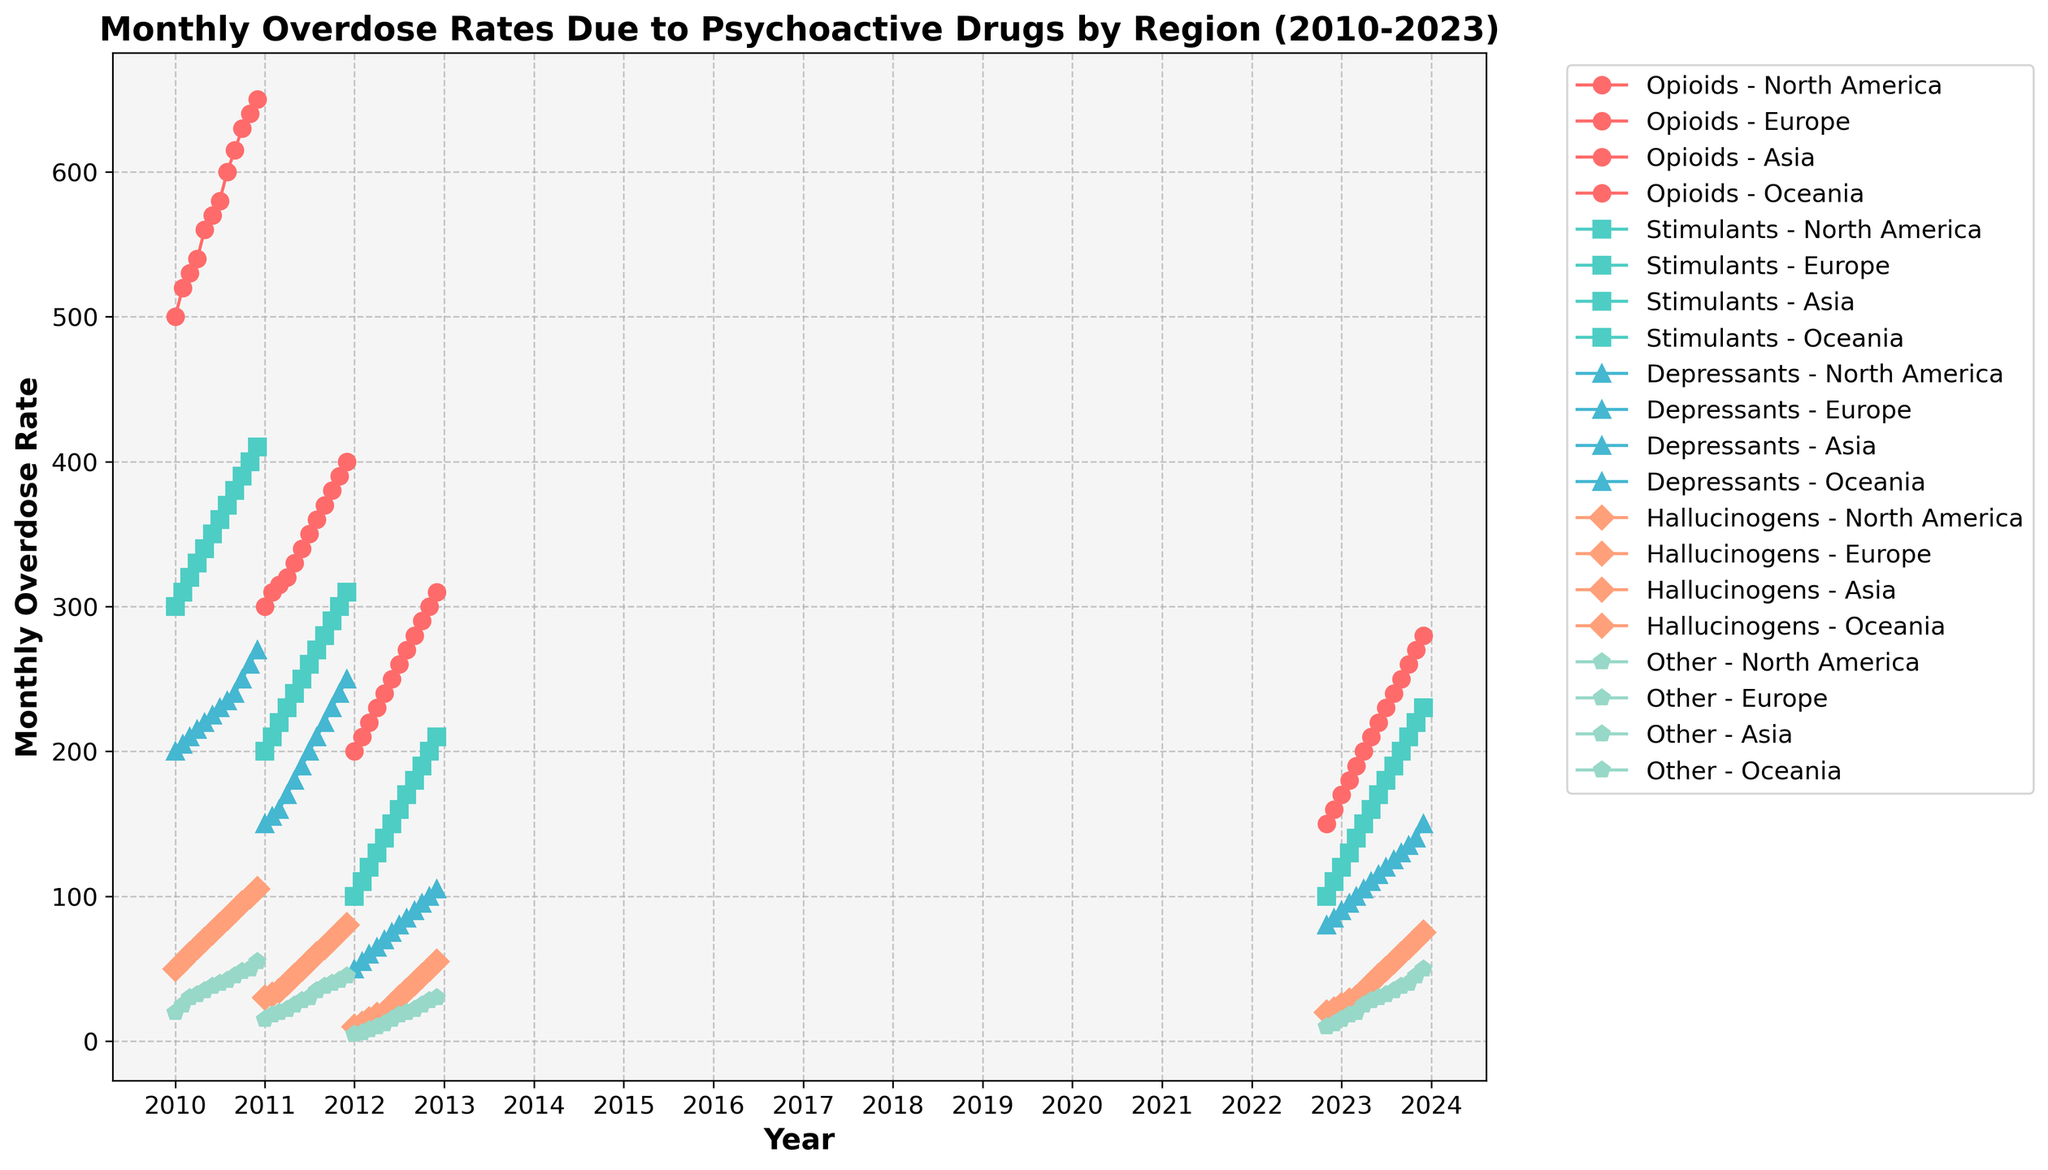What's the title of the figure? The title is typically displayed at the top of the figure and provides a summary of what the plot represents. In this case, it is located at the top center.
Answer: Monthly Overdose Rates Due to Psychoactive Drugs by Region (2010-2023) What does the y-axis represent? The y-axis represents the dependent variable, which in this case is the "Monthly Overdose Rate." This is clearly labeled on the y-axis.
Answer: Monthly Overdose Rate Which drug category in North America had the highest initial overdose rate at the start of the data range? To find this, look at the first timeframe (2010-01) for North America and compare the overdose rates of the different drug categories. Opioids had the highest rate.
Answer: Opioids In which year did Europe start seeing an increase in overdose rates due to depressants? To find this, look at the plot lines related to depressants in Europe and identify the year when these lines first start increasing. It started increasing from the data initially available in 2011-03 onwards.
Answer: 2011 Among all regions, which region reported an overdose rate for hallucinogens in 2023-08? Look for the data points corresponding to 2023-08 for each region and check the values for hallucinogens. Oceania reported data for this period.
Answer: Oceania How did the overdose rate for stimulants in Asia change from 2012-01 to 2012-12? Compare the overdose rates for stimulants in Asia at two time points, 2012-01 and 2012-12.
Answer: It increased from 100 to 210 Which region saw the highest increase in opioid overdose rates from their respective starting period to the end of the data range? To determine this, calculate the difference between the first and last data points for opioids in each region, then compare these increases. North America saw an increase from 500 to 650, Europe from 300 to 400, Asia from 200 to 310, and Oceania from 150 to 280. North America had the highest increase of 150.
Answer: North America How many distinct regions are displayed in the plot? Analyze the legend or the data points for different regions to count the number of distinct locations.
Answer: 4 Which drug category experienced the most consistent increase in overdose rates across all regions over the specified time period? Evaluate the trend lines for each drug category across all regions. Opioids have a consistent upward trend across all regions.
Answer: Opioids 